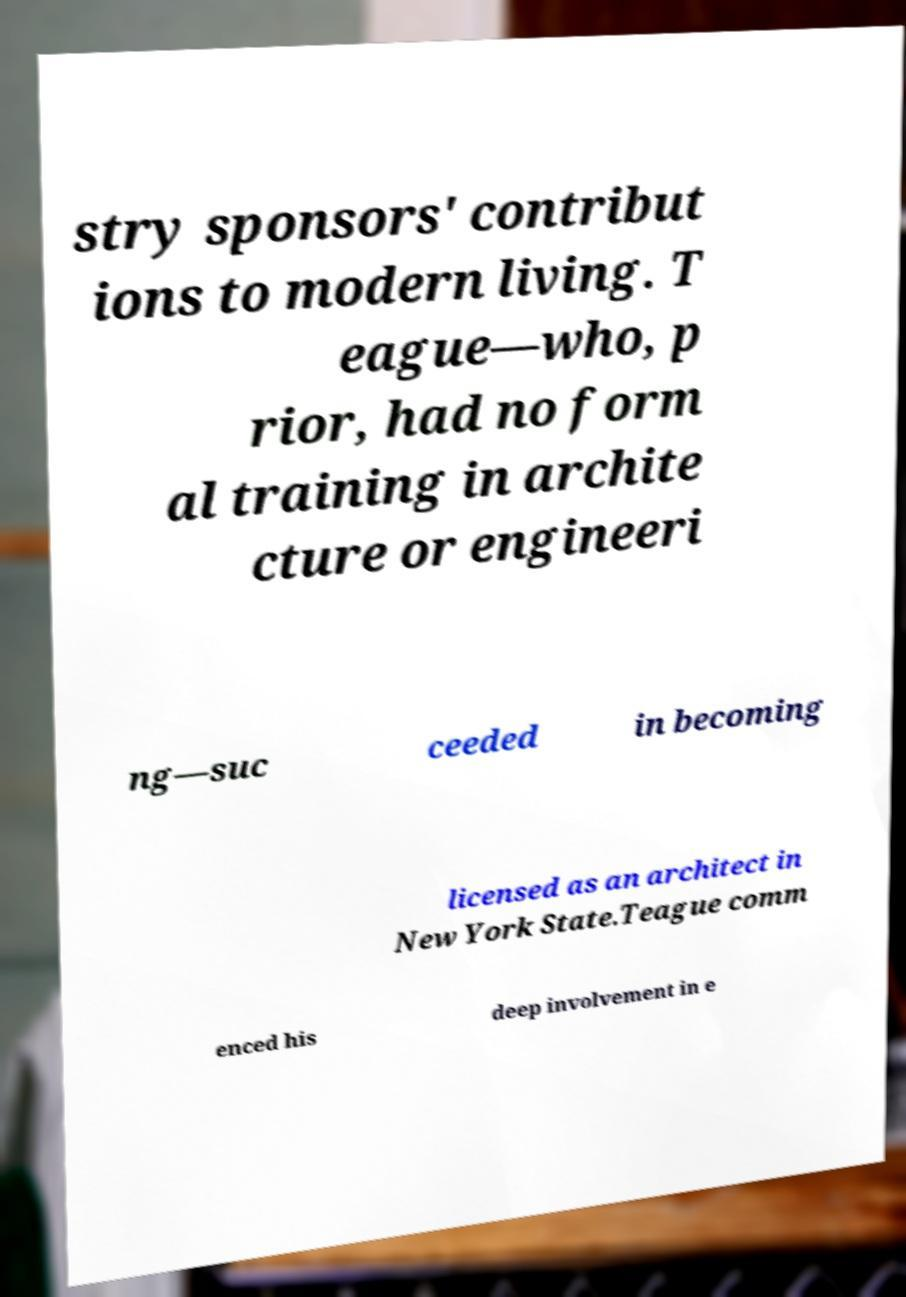There's text embedded in this image that I need extracted. Can you transcribe it verbatim? stry sponsors' contribut ions to modern living. T eague—who, p rior, had no form al training in archite cture or engineeri ng—suc ceeded in becoming licensed as an architect in New York State.Teague comm enced his deep involvement in e 